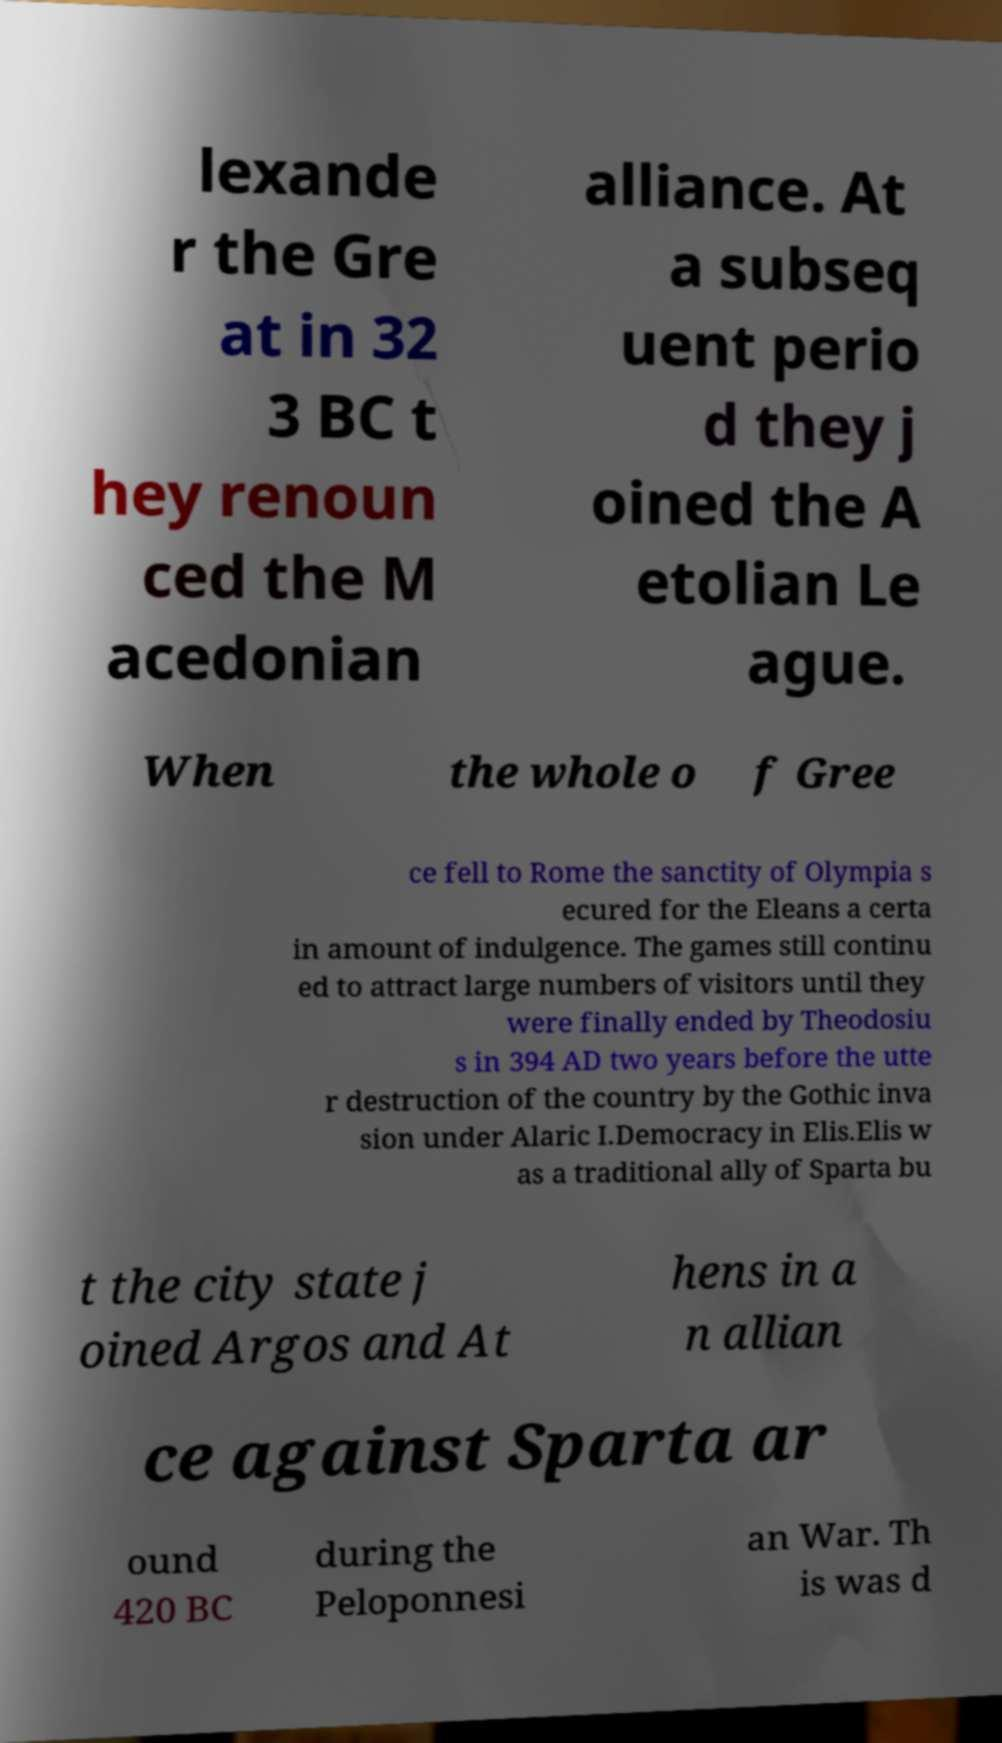Please read and relay the text visible in this image. What does it say? lexande r the Gre at in 32 3 BC t hey renoun ced the M acedonian alliance. At a subseq uent perio d they j oined the A etolian Le ague. When the whole o f Gree ce fell to Rome the sanctity of Olympia s ecured for the Eleans a certa in amount of indulgence. The games still continu ed to attract large numbers of visitors until they were finally ended by Theodosiu s in 394 AD two years before the utte r destruction of the country by the Gothic inva sion under Alaric I.Democracy in Elis.Elis w as a traditional ally of Sparta bu t the city state j oined Argos and At hens in a n allian ce against Sparta ar ound 420 BC during the Peloponnesi an War. Th is was d 